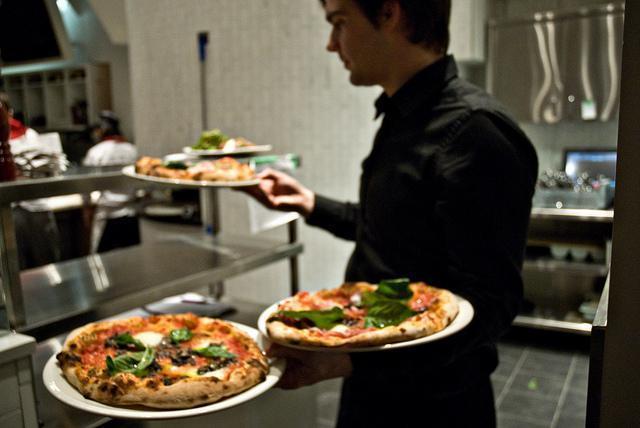How many plates of food are visible in the picture?
Give a very brief answer. 4. How many pizzas can you see?
Give a very brief answer. 3. 